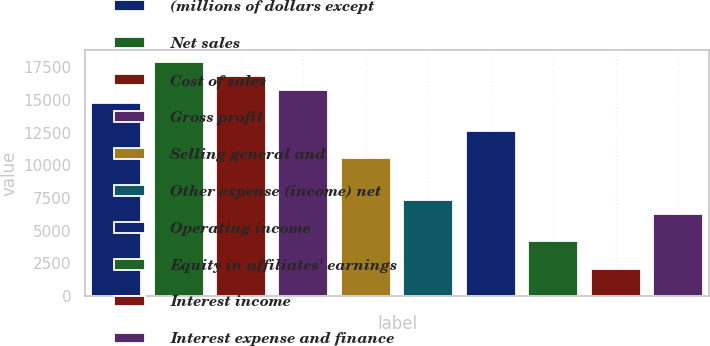Convert chart. <chart><loc_0><loc_0><loc_500><loc_500><bar_chart><fcel>(millions of dollars except<fcel>Net sales<fcel>Cost of sales<fcel>Gross profit<fcel>Selling general and<fcel>Other expense (income) net<fcel>Operating income<fcel>Equity in affiliates' earnings<fcel>Interest income<fcel>Interest expense and finance<nl><fcel>14739.7<fcel>17897.3<fcel>16844.8<fcel>15792.2<fcel>10529.6<fcel>7372.08<fcel>12634.7<fcel>4214.52<fcel>2109.48<fcel>6319.56<nl></chart> 